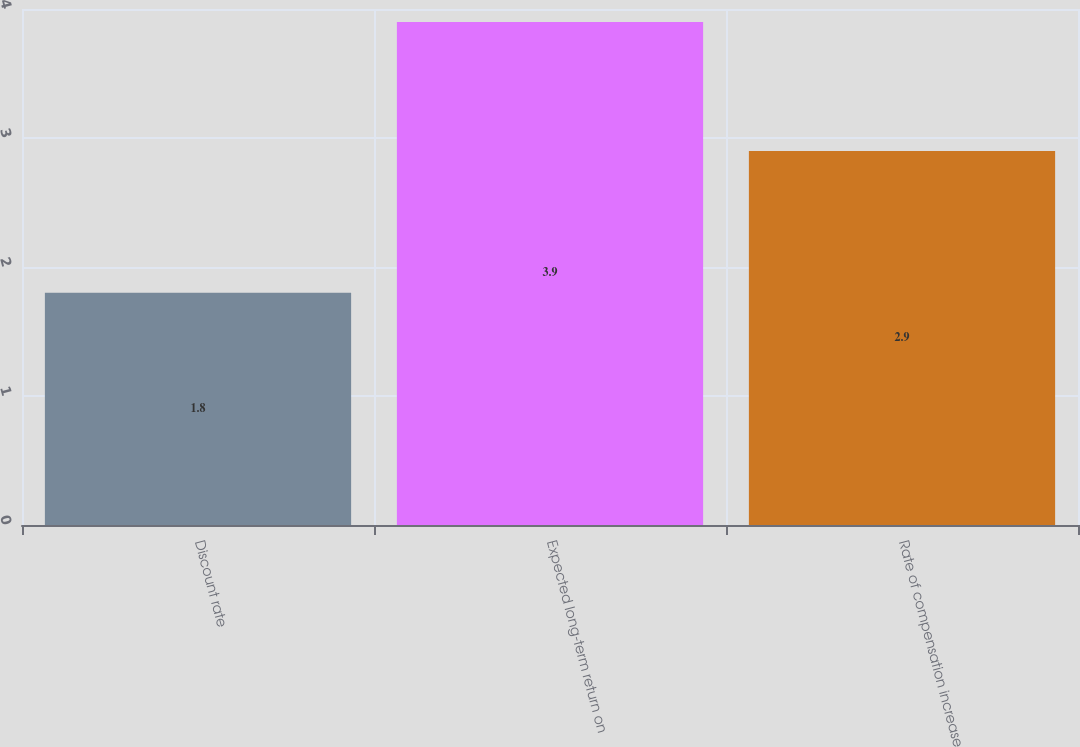Convert chart. <chart><loc_0><loc_0><loc_500><loc_500><bar_chart><fcel>Discount rate<fcel>Expected long-term return on<fcel>Rate of compensation increase<nl><fcel>1.8<fcel>3.9<fcel>2.9<nl></chart> 